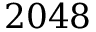<formula> <loc_0><loc_0><loc_500><loc_500>2 0 4 8</formula> 